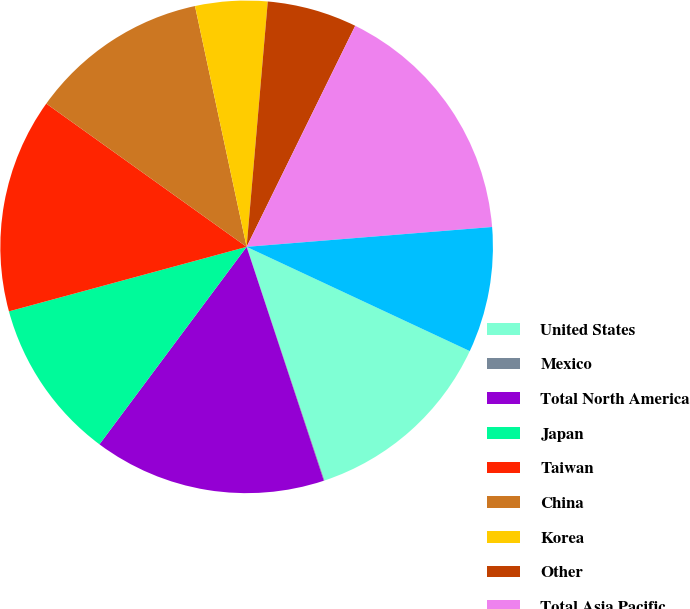<chart> <loc_0><loc_0><loc_500><loc_500><pie_chart><fcel>United States<fcel>Mexico<fcel>Total North America<fcel>Japan<fcel>Taiwan<fcel>China<fcel>Korea<fcel>Other<fcel>Total Asia Pacific<fcel>Germany<nl><fcel>12.93%<fcel>0.04%<fcel>15.27%<fcel>10.59%<fcel>14.1%<fcel>11.76%<fcel>4.73%<fcel>5.9%<fcel>16.45%<fcel>8.24%<nl></chart> 